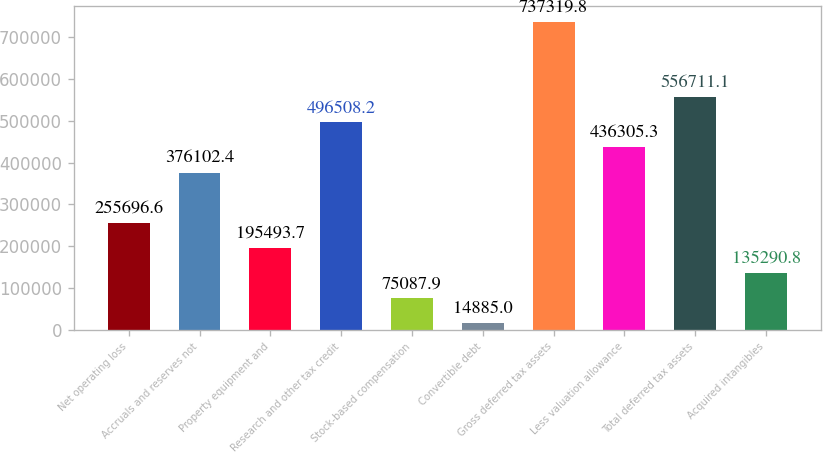<chart> <loc_0><loc_0><loc_500><loc_500><bar_chart><fcel>Net operating loss<fcel>Accruals and reserves not<fcel>Property equipment and<fcel>Research and other tax credit<fcel>Stock-based compensation<fcel>Convertible debt<fcel>Gross deferred tax assets<fcel>Less valuation allowance<fcel>Total deferred tax assets<fcel>Acquired intangibles<nl><fcel>255697<fcel>376102<fcel>195494<fcel>496508<fcel>75087.9<fcel>14885<fcel>737320<fcel>436305<fcel>556711<fcel>135291<nl></chart> 